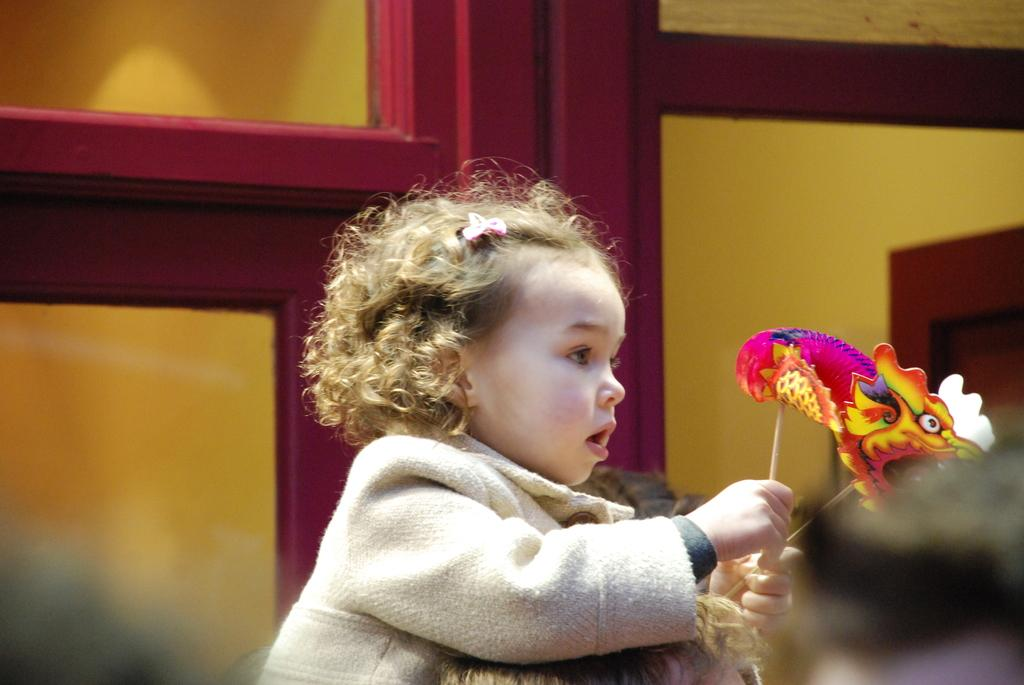Who is the main subject in the image? There is a girl in the image. What is the girl wearing? The girl is wearing a jacket. What is the girl holding in the image? The girl is holding a stick with masks on it. Can you describe the person at the bottom of the image? There is a person at the bottom of the image, but no specific details are provided. What can be seen in the background of the image? There is a glass door in the background of the image. What type of farm animals can be seen in the image? There are no farm animals present in the image. How does the girl start her journey in the image? The image does not depict the girl starting a journey, so it cannot be determined from the image. 